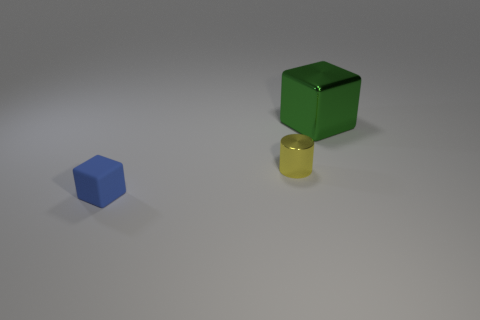Does the small matte thing have the same color as the small shiny thing?
Your response must be concise. No. What is the material of the tiny object in front of the small thing that is to the right of the blue matte object?
Give a very brief answer. Rubber. There is a green object that is the same shape as the blue object; what is it made of?
Make the answer very short. Metal. There is a cube that is right of the matte thing; is its size the same as the small blue rubber object?
Ensure brevity in your answer.  No. How many shiny things are either cylinders or green objects?
Ensure brevity in your answer.  2. The object that is in front of the large object and behind the rubber thing is made of what material?
Offer a terse response. Metal. Does the blue thing have the same material as the green cube?
Provide a short and direct response. No. There is a thing that is both to the right of the blue thing and in front of the green metal thing; what size is it?
Give a very brief answer. Small. The tiny rubber thing has what shape?
Keep it short and to the point. Cube. What number of things are either metallic cylinders or tiny things behind the blue rubber object?
Your answer should be compact. 1. 